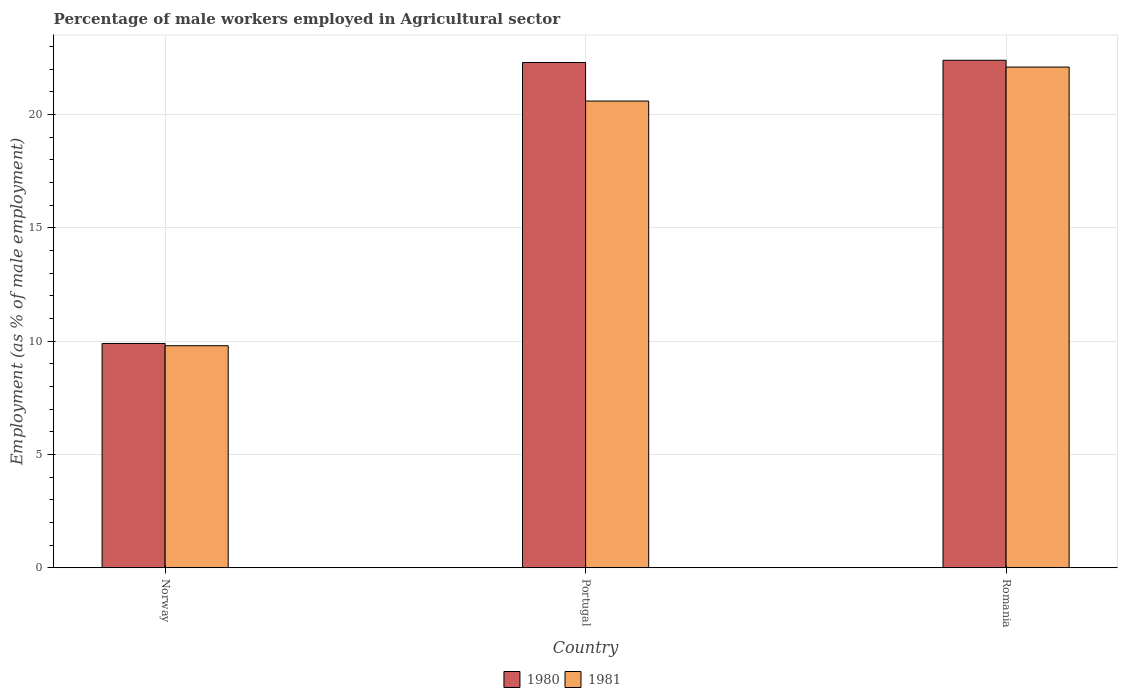How many different coloured bars are there?
Make the answer very short. 2. How many groups of bars are there?
Give a very brief answer. 3. How many bars are there on the 1st tick from the left?
Your answer should be compact. 2. How many bars are there on the 2nd tick from the right?
Your answer should be compact. 2. In how many cases, is the number of bars for a given country not equal to the number of legend labels?
Make the answer very short. 0. What is the percentage of male workers employed in Agricultural sector in 1980 in Norway?
Make the answer very short. 9.9. Across all countries, what is the maximum percentage of male workers employed in Agricultural sector in 1980?
Your answer should be very brief. 22.4. Across all countries, what is the minimum percentage of male workers employed in Agricultural sector in 1981?
Give a very brief answer. 9.8. In which country was the percentage of male workers employed in Agricultural sector in 1981 maximum?
Ensure brevity in your answer.  Romania. In which country was the percentage of male workers employed in Agricultural sector in 1980 minimum?
Your response must be concise. Norway. What is the total percentage of male workers employed in Agricultural sector in 1981 in the graph?
Provide a short and direct response. 52.5. What is the difference between the percentage of male workers employed in Agricultural sector in 1980 in Norway and that in Portugal?
Provide a succinct answer. -12.4. What is the difference between the percentage of male workers employed in Agricultural sector in 1981 in Portugal and the percentage of male workers employed in Agricultural sector in 1980 in Romania?
Your answer should be compact. -1.8. What is the average percentage of male workers employed in Agricultural sector in 1981 per country?
Keep it short and to the point. 17.5. What is the difference between the percentage of male workers employed in Agricultural sector of/in 1981 and percentage of male workers employed in Agricultural sector of/in 1980 in Norway?
Provide a short and direct response. -0.1. What is the ratio of the percentage of male workers employed in Agricultural sector in 1980 in Norway to that in Portugal?
Your response must be concise. 0.44. Is the percentage of male workers employed in Agricultural sector in 1981 in Norway less than that in Romania?
Your response must be concise. Yes. Is the difference between the percentage of male workers employed in Agricultural sector in 1981 in Norway and Romania greater than the difference between the percentage of male workers employed in Agricultural sector in 1980 in Norway and Romania?
Your response must be concise. Yes. What is the difference between the highest and the second highest percentage of male workers employed in Agricultural sector in 1980?
Your answer should be very brief. -12.5. What is the difference between the highest and the lowest percentage of male workers employed in Agricultural sector in 1981?
Provide a short and direct response. 12.3. What does the 1st bar from the right in Romania represents?
Provide a succinct answer. 1981. How many bars are there?
Your answer should be compact. 6. Are all the bars in the graph horizontal?
Offer a very short reply. No. How many countries are there in the graph?
Provide a short and direct response. 3. What is the difference between two consecutive major ticks on the Y-axis?
Offer a terse response. 5. What is the title of the graph?
Ensure brevity in your answer.  Percentage of male workers employed in Agricultural sector. Does "1971" appear as one of the legend labels in the graph?
Give a very brief answer. No. What is the label or title of the X-axis?
Provide a succinct answer. Country. What is the label or title of the Y-axis?
Provide a succinct answer. Employment (as % of male employment). What is the Employment (as % of male employment) in 1980 in Norway?
Your response must be concise. 9.9. What is the Employment (as % of male employment) of 1981 in Norway?
Give a very brief answer. 9.8. What is the Employment (as % of male employment) of 1980 in Portugal?
Make the answer very short. 22.3. What is the Employment (as % of male employment) in 1981 in Portugal?
Your response must be concise. 20.6. What is the Employment (as % of male employment) of 1980 in Romania?
Offer a terse response. 22.4. What is the Employment (as % of male employment) of 1981 in Romania?
Provide a succinct answer. 22.1. Across all countries, what is the maximum Employment (as % of male employment) in 1980?
Give a very brief answer. 22.4. Across all countries, what is the maximum Employment (as % of male employment) in 1981?
Your response must be concise. 22.1. Across all countries, what is the minimum Employment (as % of male employment) of 1980?
Ensure brevity in your answer.  9.9. Across all countries, what is the minimum Employment (as % of male employment) in 1981?
Ensure brevity in your answer.  9.8. What is the total Employment (as % of male employment) in 1980 in the graph?
Give a very brief answer. 54.6. What is the total Employment (as % of male employment) of 1981 in the graph?
Offer a very short reply. 52.5. What is the difference between the Employment (as % of male employment) in 1980 in Norway and that in Portugal?
Your answer should be very brief. -12.4. What is the difference between the Employment (as % of male employment) in 1981 in Norway and that in Portugal?
Your answer should be compact. -10.8. What is the difference between the Employment (as % of male employment) of 1981 in Norway and that in Romania?
Give a very brief answer. -12.3. What is the difference between the Employment (as % of male employment) of 1980 in Portugal and that in Romania?
Offer a terse response. -0.1. What is the difference between the Employment (as % of male employment) of 1980 in Norway and the Employment (as % of male employment) of 1981 in Portugal?
Keep it short and to the point. -10.7. What is the difference between the Employment (as % of male employment) in 1980 in Norway and the Employment (as % of male employment) in 1981 in Romania?
Your answer should be very brief. -12.2. What is the difference between the Employment (as % of male employment) in 1980 in Portugal and the Employment (as % of male employment) in 1981 in Romania?
Make the answer very short. 0.2. What is the difference between the Employment (as % of male employment) in 1980 and Employment (as % of male employment) in 1981 in Norway?
Provide a short and direct response. 0.1. What is the difference between the Employment (as % of male employment) in 1980 and Employment (as % of male employment) in 1981 in Romania?
Offer a very short reply. 0.3. What is the ratio of the Employment (as % of male employment) in 1980 in Norway to that in Portugal?
Provide a short and direct response. 0.44. What is the ratio of the Employment (as % of male employment) in 1981 in Norway to that in Portugal?
Your response must be concise. 0.48. What is the ratio of the Employment (as % of male employment) in 1980 in Norway to that in Romania?
Your response must be concise. 0.44. What is the ratio of the Employment (as % of male employment) of 1981 in Norway to that in Romania?
Your answer should be very brief. 0.44. What is the ratio of the Employment (as % of male employment) in 1981 in Portugal to that in Romania?
Provide a succinct answer. 0.93. What is the difference between the highest and the second highest Employment (as % of male employment) of 1980?
Make the answer very short. 0.1. What is the difference between the highest and the second highest Employment (as % of male employment) in 1981?
Your answer should be very brief. 1.5. What is the difference between the highest and the lowest Employment (as % of male employment) in 1980?
Your answer should be compact. 12.5. 